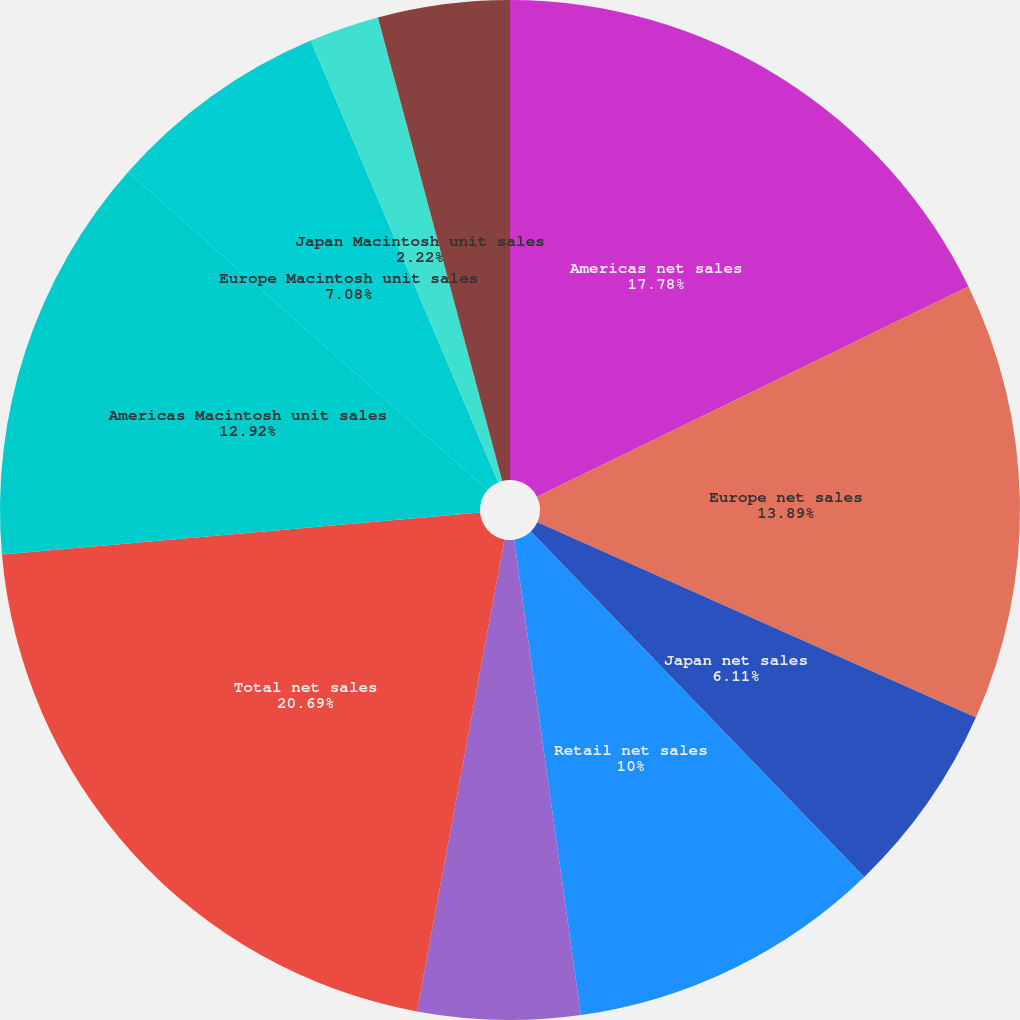Convert chart to OTSL. <chart><loc_0><loc_0><loc_500><loc_500><pie_chart><fcel>Americas net sales<fcel>Europe net sales<fcel>Japan net sales<fcel>Retail net sales<fcel>Other Segments net sales (a)<fcel>Total net sales<fcel>Americas Macintosh unit sales<fcel>Europe Macintosh unit sales<fcel>Japan Macintosh unit sales<fcel>Retail Macintosh unit sales<nl><fcel>17.78%<fcel>13.89%<fcel>6.11%<fcel>10.0%<fcel>5.14%<fcel>20.69%<fcel>12.92%<fcel>7.08%<fcel>2.22%<fcel>4.17%<nl></chart> 